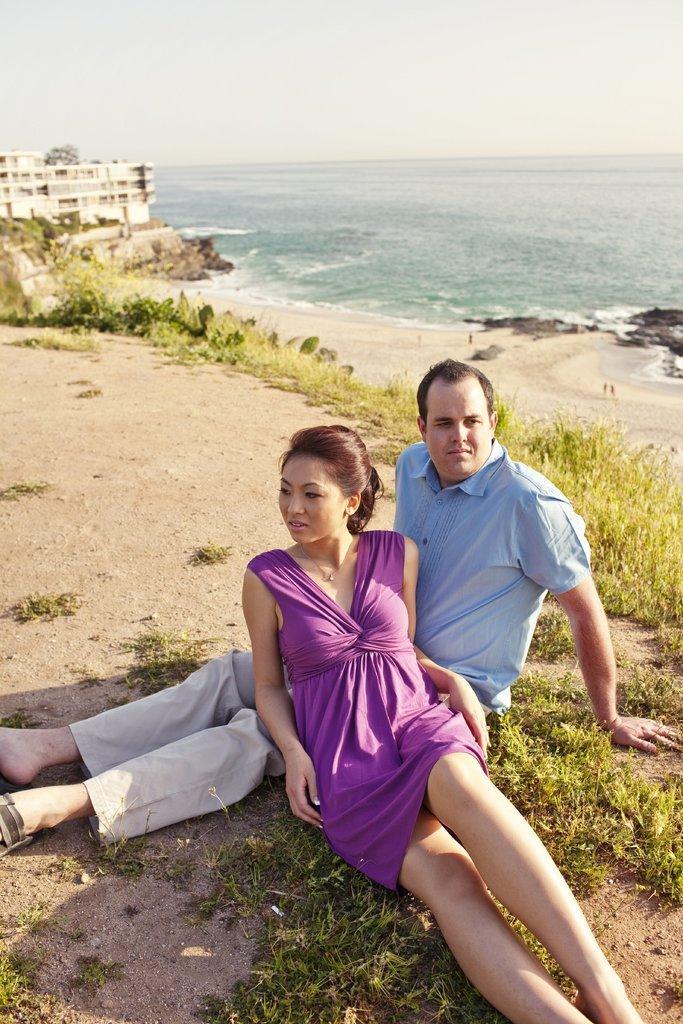Describe this image in one or two sentences. In this image, we can see women and men are on the ground. Here there are few plants, grass. Top of the image, we can see the ocean, building and sky. 